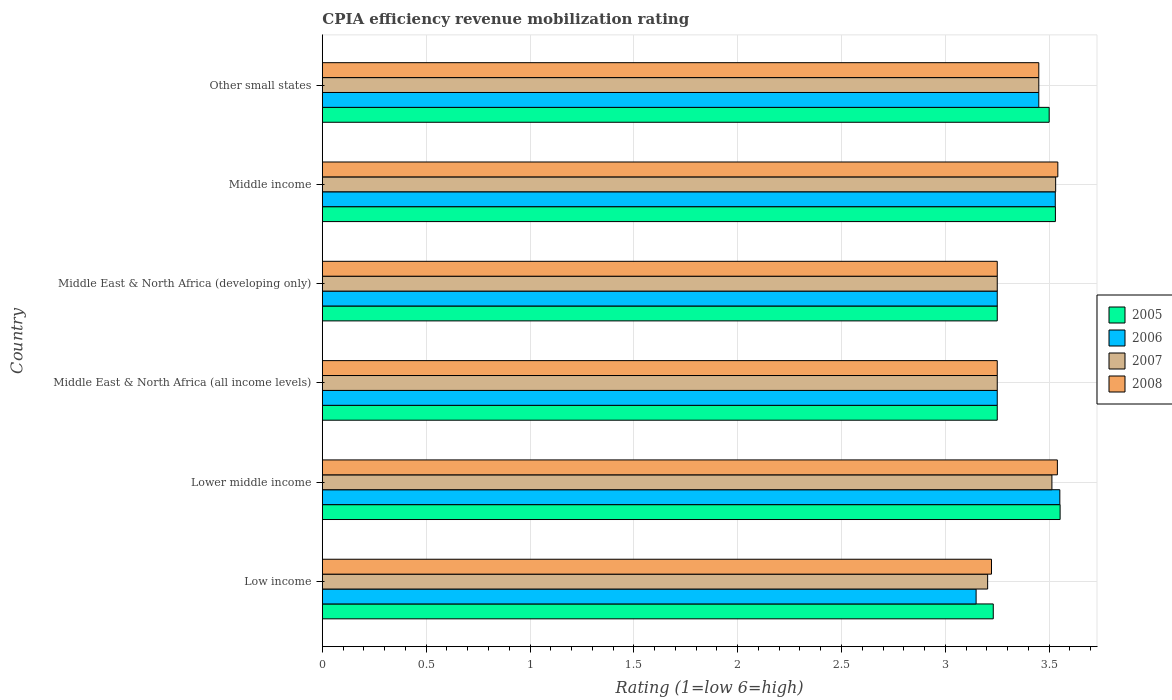How many different coloured bars are there?
Keep it short and to the point. 4. Are the number of bars per tick equal to the number of legend labels?
Your response must be concise. Yes. Are the number of bars on each tick of the Y-axis equal?
Offer a terse response. Yes. How many bars are there on the 2nd tick from the top?
Make the answer very short. 4. How many bars are there on the 1st tick from the bottom?
Ensure brevity in your answer.  4. In how many cases, is the number of bars for a given country not equal to the number of legend labels?
Provide a succinct answer. 0. Across all countries, what is the maximum CPIA rating in 2005?
Provide a short and direct response. 3.55. Across all countries, what is the minimum CPIA rating in 2007?
Provide a succinct answer. 3.2. In which country was the CPIA rating in 2007 minimum?
Provide a succinct answer. Low income. What is the total CPIA rating in 2005 in the graph?
Your response must be concise. 20.31. What is the difference between the CPIA rating in 2007 in Low income and that in Middle income?
Offer a very short reply. -0.33. What is the difference between the CPIA rating in 2006 in Lower middle income and the CPIA rating in 2008 in Middle income?
Give a very brief answer. 0.01. What is the average CPIA rating in 2008 per country?
Your answer should be compact. 3.38. What is the difference between the CPIA rating in 2006 and CPIA rating in 2007 in Middle East & North Africa (all income levels)?
Offer a terse response. 0. What is the ratio of the CPIA rating in 2005 in Middle East & North Africa (all income levels) to that in Middle East & North Africa (developing only)?
Provide a short and direct response. 1. What is the difference between the highest and the second highest CPIA rating in 2008?
Keep it short and to the point. 0. What is the difference between the highest and the lowest CPIA rating in 2008?
Offer a very short reply. 0.32. Is the sum of the CPIA rating in 2008 in Middle East & North Africa (all income levels) and Middle East & North Africa (developing only) greater than the maximum CPIA rating in 2006 across all countries?
Make the answer very short. Yes. Is it the case that in every country, the sum of the CPIA rating in 2005 and CPIA rating in 2007 is greater than the sum of CPIA rating in 2006 and CPIA rating in 2008?
Your answer should be very brief. No. What does the 4th bar from the top in Middle East & North Africa (developing only) represents?
Offer a very short reply. 2005. What does the 1st bar from the bottom in Middle income represents?
Ensure brevity in your answer.  2005. How many bars are there?
Give a very brief answer. 24. How many countries are there in the graph?
Your answer should be very brief. 6. Are the values on the major ticks of X-axis written in scientific E-notation?
Give a very brief answer. No. Where does the legend appear in the graph?
Your answer should be compact. Center right. How many legend labels are there?
Offer a terse response. 4. How are the legend labels stacked?
Your answer should be very brief. Vertical. What is the title of the graph?
Ensure brevity in your answer.  CPIA efficiency revenue mobilization rating. Does "1986" appear as one of the legend labels in the graph?
Offer a terse response. No. What is the label or title of the X-axis?
Keep it short and to the point. Rating (1=low 6=high). What is the label or title of the Y-axis?
Your response must be concise. Country. What is the Rating (1=low 6=high) of 2005 in Low income?
Your answer should be very brief. 3.23. What is the Rating (1=low 6=high) of 2006 in Low income?
Provide a succinct answer. 3.15. What is the Rating (1=low 6=high) of 2007 in Low income?
Your response must be concise. 3.2. What is the Rating (1=low 6=high) in 2008 in Low income?
Provide a short and direct response. 3.22. What is the Rating (1=low 6=high) in 2005 in Lower middle income?
Your answer should be very brief. 3.55. What is the Rating (1=low 6=high) in 2006 in Lower middle income?
Provide a succinct answer. 3.55. What is the Rating (1=low 6=high) of 2007 in Lower middle income?
Offer a very short reply. 3.51. What is the Rating (1=low 6=high) of 2008 in Lower middle income?
Provide a succinct answer. 3.54. What is the Rating (1=low 6=high) in 2006 in Middle East & North Africa (all income levels)?
Keep it short and to the point. 3.25. What is the Rating (1=low 6=high) of 2007 in Middle East & North Africa (all income levels)?
Offer a terse response. 3.25. What is the Rating (1=low 6=high) of 2008 in Middle East & North Africa (all income levels)?
Offer a terse response. 3.25. What is the Rating (1=low 6=high) of 2006 in Middle East & North Africa (developing only)?
Provide a succinct answer. 3.25. What is the Rating (1=low 6=high) in 2007 in Middle East & North Africa (developing only)?
Provide a succinct answer. 3.25. What is the Rating (1=low 6=high) of 2008 in Middle East & North Africa (developing only)?
Provide a succinct answer. 3.25. What is the Rating (1=low 6=high) of 2005 in Middle income?
Your answer should be compact. 3.53. What is the Rating (1=low 6=high) in 2006 in Middle income?
Offer a very short reply. 3.53. What is the Rating (1=low 6=high) in 2007 in Middle income?
Offer a very short reply. 3.53. What is the Rating (1=low 6=high) of 2008 in Middle income?
Your answer should be very brief. 3.54. What is the Rating (1=low 6=high) in 2006 in Other small states?
Offer a terse response. 3.45. What is the Rating (1=low 6=high) of 2007 in Other small states?
Your answer should be very brief. 3.45. What is the Rating (1=low 6=high) of 2008 in Other small states?
Offer a very short reply. 3.45. Across all countries, what is the maximum Rating (1=low 6=high) in 2005?
Give a very brief answer. 3.55. Across all countries, what is the maximum Rating (1=low 6=high) of 2006?
Your answer should be compact. 3.55. Across all countries, what is the maximum Rating (1=low 6=high) in 2007?
Give a very brief answer. 3.53. Across all countries, what is the maximum Rating (1=low 6=high) of 2008?
Your answer should be very brief. 3.54. Across all countries, what is the minimum Rating (1=low 6=high) in 2005?
Offer a very short reply. 3.23. Across all countries, what is the minimum Rating (1=low 6=high) in 2006?
Your answer should be very brief. 3.15. Across all countries, what is the minimum Rating (1=low 6=high) in 2007?
Offer a terse response. 3.2. Across all countries, what is the minimum Rating (1=low 6=high) in 2008?
Your answer should be compact. 3.22. What is the total Rating (1=low 6=high) of 2005 in the graph?
Your answer should be very brief. 20.31. What is the total Rating (1=low 6=high) in 2006 in the graph?
Your response must be concise. 20.18. What is the total Rating (1=low 6=high) of 2007 in the graph?
Your response must be concise. 20.2. What is the total Rating (1=low 6=high) in 2008 in the graph?
Ensure brevity in your answer.  20.25. What is the difference between the Rating (1=low 6=high) in 2005 in Low income and that in Lower middle income?
Provide a short and direct response. -0.32. What is the difference between the Rating (1=low 6=high) in 2006 in Low income and that in Lower middle income?
Provide a short and direct response. -0.4. What is the difference between the Rating (1=low 6=high) of 2007 in Low income and that in Lower middle income?
Provide a short and direct response. -0.31. What is the difference between the Rating (1=low 6=high) of 2008 in Low income and that in Lower middle income?
Give a very brief answer. -0.32. What is the difference between the Rating (1=low 6=high) of 2005 in Low income and that in Middle East & North Africa (all income levels)?
Ensure brevity in your answer.  -0.02. What is the difference between the Rating (1=low 6=high) of 2006 in Low income and that in Middle East & North Africa (all income levels)?
Keep it short and to the point. -0.1. What is the difference between the Rating (1=low 6=high) in 2007 in Low income and that in Middle East & North Africa (all income levels)?
Ensure brevity in your answer.  -0.05. What is the difference between the Rating (1=low 6=high) in 2008 in Low income and that in Middle East & North Africa (all income levels)?
Provide a succinct answer. -0.03. What is the difference between the Rating (1=low 6=high) in 2005 in Low income and that in Middle East & North Africa (developing only)?
Ensure brevity in your answer.  -0.02. What is the difference between the Rating (1=low 6=high) of 2006 in Low income and that in Middle East & North Africa (developing only)?
Keep it short and to the point. -0.1. What is the difference between the Rating (1=low 6=high) of 2007 in Low income and that in Middle East & North Africa (developing only)?
Your answer should be compact. -0.05. What is the difference between the Rating (1=low 6=high) in 2008 in Low income and that in Middle East & North Africa (developing only)?
Provide a succinct answer. -0.03. What is the difference between the Rating (1=low 6=high) in 2005 in Low income and that in Middle income?
Ensure brevity in your answer.  -0.3. What is the difference between the Rating (1=low 6=high) of 2006 in Low income and that in Middle income?
Your response must be concise. -0.38. What is the difference between the Rating (1=low 6=high) of 2007 in Low income and that in Middle income?
Keep it short and to the point. -0.33. What is the difference between the Rating (1=low 6=high) of 2008 in Low income and that in Middle income?
Your answer should be compact. -0.32. What is the difference between the Rating (1=low 6=high) of 2005 in Low income and that in Other small states?
Your response must be concise. -0.27. What is the difference between the Rating (1=low 6=high) in 2006 in Low income and that in Other small states?
Your response must be concise. -0.3. What is the difference between the Rating (1=low 6=high) of 2007 in Low income and that in Other small states?
Give a very brief answer. -0.25. What is the difference between the Rating (1=low 6=high) of 2008 in Low income and that in Other small states?
Your answer should be very brief. -0.23. What is the difference between the Rating (1=low 6=high) in 2005 in Lower middle income and that in Middle East & North Africa (all income levels)?
Offer a terse response. 0.3. What is the difference between the Rating (1=low 6=high) in 2006 in Lower middle income and that in Middle East & North Africa (all income levels)?
Your answer should be compact. 0.3. What is the difference between the Rating (1=low 6=high) in 2007 in Lower middle income and that in Middle East & North Africa (all income levels)?
Make the answer very short. 0.26. What is the difference between the Rating (1=low 6=high) of 2008 in Lower middle income and that in Middle East & North Africa (all income levels)?
Your response must be concise. 0.29. What is the difference between the Rating (1=low 6=high) of 2005 in Lower middle income and that in Middle East & North Africa (developing only)?
Offer a terse response. 0.3. What is the difference between the Rating (1=low 6=high) of 2006 in Lower middle income and that in Middle East & North Africa (developing only)?
Keep it short and to the point. 0.3. What is the difference between the Rating (1=low 6=high) of 2007 in Lower middle income and that in Middle East & North Africa (developing only)?
Offer a very short reply. 0.26. What is the difference between the Rating (1=low 6=high) in 2008 in Lower middle income and that in Middle East & North Africa (developing only)?
Keep it short and to the point. 0.29. What is the difference between the Rating (1=low 6=high) in 2005 in Lower middle income and that in Middle income?
Offer a terse response. 0.02. What is the difference between the Rating (1=low 6=high) of 2006 in Lower middle income and that in Middle income?
Your answer should be compact. 0.02. What is the difference between the Rating (1=low 6=high) in 2007 in Lower middle income and that in Middle income?
Make the answer very short. -0.02. What is the difference between the Rating (1=low 6=high) of 2008 in Lower middle income and that in Middle income?
Ensure brevity in your answer.  -0. What is the difference between the Rating (1=low 6=high) in 2005 in Lower middle income and that in Other small states?
Your answer should be very brief. 0.05. What is the difference between the Rating (1=low 6=high) of 2006 in Lower middle income and that in Other small states?
Provide a succinct answer. 0.1. What is the difference between the Rating (1=low 6=high) of 2007 in Lower middle income and that in Other small states?
Keep it short and to the point. 0.06. What is the difference between the Rating (1=low 6=high) of 2008 in Lower middle income and that in Other small states?
Provide a succinct answer. 0.09. What is the difference between the Rating (1=low 6=high) in 2007 in Middle East & North Africa (all income levels) and that in Middle East & North Africa (developing only)?
Provide a short and direct response. 0. What is the difference between the Rating (1=low 6=high) in 2005 in Middle East & North Africa (all income levels) and that in Middle income?
Make the answer very short. -0.28. What is the difference between the Rating (1=low 6=high) of 2006 in Middle East & North Africa (all income levels) and that in Middle income?
Your answer should be very brief. -0.28. What is the difference between the Rating (1=low 6=high) in 2007 in Middle East & North Africa (all income levels) and that in Middle income?
Your response must be concise. -0.28. What is the difference between the Rating (1=low 6=high) in 2008 in Middle East & North Africa (all income levels) and that in Middle income?
Provide a succinct answer. -0.29. What is the difference between the Rating (1=low 6=high) of 2008 in Middle East & North Africa (all income levels) and that in Other small states?
Your answer should be very brief. -0.2. What is the difference between the Rating (1=low 6=high) in 2005 in Middle East & North Africa (developing only) and that in Middle income?
Your answer should be very brief. -0.28. What is the difference between the Rating (1=low 6=high) of 2006 in Middle East & North Africa (developing only) and that in Middle income?
Offer a terse response. -0.28. What is the difference between the Rating (1=low 6=high) of 2007 in Middle East & North Africa (developing only) and that in Middle income?
Ensure brevity in your answer.  -0.28. What is the difference between the Rating (1=low 6=high) of 2008 in Middle East & North Africa (developing only) and that in Middle income?
Your answer should be very brief. -0.29. What is the difference between the Rating (1=low 6=high) in 2006 in Middle East & North Africa (developing only) and that in Other small states?
Your response must be concise. -0.2. What is the difference between the Rating (1=low 6=high) in 2006 in Middle income and that in Other small states?
Your answer should be compact. 0.08. What is the difference between the Rating (1=low 6=high) of 2007 in Middle income and that in Other small states?
Keep it short and to the point. 0.08. What is the difference between the Rating (1=low 6=high) of 2008 in Middle income and that in Other small states?
Your response must be concise. 0.09. What is the difference between the Rating (1=low 6=high) in 2005 in Low income and the Rating (1=low 6=high) in 2006 in Lower middle income?
Provide a succinct answer. -0.32. What is the difference between the Rating (1=low 6=high) in 2005 in Low income and the Rating (1=low 6=high) in 2007 in Lower middle income?
Your answer should be compact. -0.28. What is the difference between the Rating (1=low 6=high) of 2005 in Low income and the Rating (1=low 6=high) of 2008 in Lower middle income?
Provide a short and direct response. -0.31. What is the difference between the Rating (1=low 6=high) in 2006 in Low income and the Rating (1=low 6=high) in 2007 in Lower middle income?
Offer a very short reply. -0.36. What is the difference between the Rating (1=low 6=high) in 2006 in Low income and the Rating (1=low 6=high) in 2008 in Lower middle income?
Your answer should be compact. -0.39. What is the difference between the Rating (1=low 6=high) in 2007 in Low income and the Rating (1=low 6=high) in 2008 in Lower middle income?
Provide a succinct answer. -0.34. What is the difference between the Rating (1=low 6=high) of 2005 in Low income and the Rating (1=low 6=high) of 2006 in Middle East & North Africa (all income levels)?
Your answer should be compact. -0.02. What is the difference between the Rating (1=low 6=high) in 2005 in Low income and the Rating (1=low 6=high) in 2007 in Middle East & North Africa (all income levels)?
Your answer should be very brief. -0.02. What is the difference between the Rating (1=low 6=high) of 2005 in Low income and the Rating (1=low 6=high) of 2008 in Middle East & North Africa (all income levels)?
Offer a terse response. -0.02. What is the difference between the Rating (1=low 6=high) of 2006 in Low income and the Rating (1=low 6=high) of 2007 in Middle East & North Africa (all income levels)?
Provide a succinct answer. -0.1. What is the difference between the Rating (1=low 6=high) of 2006 in Low income and the Rating (1=low 6=high) of 2008 in Middle East & North Africa (all income levels)?
Ensure brevity in your answer.  -0.1. What is the difference between the Rating (1=low 6=high) of 2007 in Low income and the Rating (1=low 6=high) of 2008 in Middle East & North Africa (all income levels)?
Provide a succinct answer. -0.05. What is the difference between the Rating (1=low 6=high) in 2005 in Low income and the Rating (1=low 6=high) in 2006 in Middle East & North Africa (developing only)?
Offer a very short reply. -0.02. What is the difference between the Rating (1=low 6=high) in 2005 in Low income and the Rating (1=low 6=high) in 2007 in Middle East & North Africa (developing only)?
Provide a succinct answer. -0.02. What is the difference between the Rating (1=low 6=high) in 2005 in Low income and the Rating (1=low 6=high) in 2008 in Middle East & North Africa (developing only)?
Offer a terse response. -0.02. What is the difference between the Rating (1=low 6=high) of 2006 in Low income and the Rating (1=low 6=high) of 2007 in Middle East & North Africa (developing only)?
Your answer should be very brief. -0.1. What is the difference between the Rating (1=low 6=high) of 2006 in Low income and the Rating (1=low 6=high) of 2008 in Middle East & North Africa (developing only)?
Provide a short and direct response. -0.1. What is the difference between the Rating (1=low 6=high) in 2007 in Low income and the Rating (1=low 6=high) in 2008 in Middle East & North Africa (developing only)?
Your answer should be compact. -0.05. What is the difference between the Rating (1=low 6=high) of 2005 in Low income and the Rating (1=low 6=high) of 2006 in Middle income?
Provide a succinct answer. -0.3. What is the difference between the Rating (1=low 6=high) in 2005 in Low income and the Rating (1=low 6=high) in 2007 in Middle income?
Provide a succinct answer. -0.3. What is the difference between the Rating (1=low 6=high) of 2005 in Low income and the Rating (1=low 6=high) of 2008 in Middle income?
Make the answer very short. -0.31. What is the difference between the Rating (1=low 6=high) of 2006 in Low income and the Rating (1=low 6=high) of 2007 in Middle income?
Your response must be concise. -0.38. What is the difference between the Rating (1=low 6=high) of 2006 in Low income and the Rating (1=low 6=high) of 2008 in Middle income?
Offer a very short reply. -0.39. What is the difference between the Rating (1=low 6=high) of 2007 in Low income and the Rating (1=low 6=high) of 2008 in Middle income?
Give a very brief answer. -0.34. What is the difference between the Rating (1=low 6=high) of 2005 in Low income and the Rating (1=low 6=high) of 2006 in Other small states?
Make the answer very short. -0.22. What is the difference between the Rating (1=low 6=high) of 2005 in Low income and the Rating (1=low 6=high) of 2007 in Other small states?
Give a very brief answer. -0.22. What is the difference between the Rating (1=low 6=high) in 2005 in Low income and the Rating (1=low 6=high) in 2008 in Other small states?
Make the answer very short. -0.22. What is the difference between the Rating (1=low 6=high) of 2006 in Low income and the Rating (1=low 6=high) of 2007 in Other small states?
Ensure brevity in your answer.  -0.3. What is the difference between the Rating (1=low 6=high) in 2006 in Low income and the Rating (1=low 6=high) in 2008 in Other small states?
Offer a terse response. -0.3. What is the difference between the Rating (1=low 6=high) of 2007 in Low income and the Rating (1=low 6=high) of 2008 in Other small states?
Provide a short and direct response. -0.25. What is the difference between the Rating (1=low 6=high) in 2005 in Lower middle income and the Rating (1=low 6=high) in 2006 in Middle East & North Africa (all income levels)?
Your response must be concise. 0.3. What is the difference between the Rating (1=low 6=high) of 2005 in Lower middle income and the Rating (1=low 6=high) of 2007 in Middle East & North Africa (all income levels)?
Offer a very short reply. 0.3. What is the difference between the Rating (1=low 6=high) of 2005 in Lower middle income and the Rating (1=low 6=high) of 2008 in Middle East & North Africa (all income levels)?
Make the answer very short. 0.3. What is the difference between the Rating (1=low 6=high) of 2006 in Lower middle income and the Rating (1=low 6=high) of 2007 in Middle East & North Africa (all income levels)?
Make the answer very short. 0.3. What is the difference between the Rating (1=low 6=high) in 2006 in Lower middle income and the Rating (1=low 6=high) in 2008 in Middle East & North Africa (all income levels)?
Provide a short and direct response. 0.3. What is the difference between the Rating (1=low 6=high) of 2007 in Lower middle income and the Rating (1=low 6=high) of 2008 in Middle East & North Africa (all income levels)?
Provide a succinct answer. 0.26. What is the difference between the Rating (1=low 6=high) of 2005 in Lower middle income and the Rating (1=low 6=high) of 2006 in Middle East & North Africa (developing only)?
Offer a very short reply. 0.3. What is the difference between the Rating (1=low 6=high) in 2005 in Lower middle income and the Rating (1=low 6=high) in 2007 in Middle East & North Africa (developing only)?
Offer a very short reply. 0.3. What is the difference between the Rating (1=low 6=high) in 2005 in Lower middle income and the Rating (1=low 6=high) in 2008 in Middle East & North Africa (developing only)?
Your answer should be compact. 0.3. What is the difference between the Rating (1=low 6=high) in 2006 in Lower middle income and the Rating (1=low 6=high) in 2007 in Middle East & North Africa (developing only)?
Offer a very short reply. 0.3. What is the difference between the Rating (1=low 6=high) of 2006 in Lower middle income and the Rating (1=low 6=high) of 2008 in Middle East & North Africa (developing only)?
Your response must be concise. 0.3. What is the difference between the Rating (1=low 6=high) in 2007 in Lower middle income and the Rating (1=low 6=high) in 2008 in Middle East & North Africa (developing only)?
Your answer should be very brief. 0.26. What is the difference between the Rating (1=low 6=high) in 2005 in Lower middle income and the Rating (1=low 6=high) in 2006 in Middle income?
Offer a very short reply. 0.02. What is the difference between the Rating (1=low 6=high) of 2005 in Lower middle income and the Rating (1=low 6=high) of 2007 in Middle income?
Offer a terse response. 0.02. What is the difference between the Rating (1=low 6=high) in 2005 in Lower middle income and the Rating (1=low 6=high) in 2008 in Middle income?
Provide a short and direct response. 0.01. What is the difference between the Rating (1=low 6=high) of 2006 in Lower middle income and the Rating (1=low 6=high) of 2007 in Middle income?
Make the answer very short. 0.02. What is the difference between the Rating (1=low 6=high) in 2006 in Lower middle income and the Rating (1=low 6=high) in 2008 in Middle income?
Provide a succinct answer. 0.01. What is the difference between the Rating (1=low 6=high) of 2007 in Lower middle income and the Rating (1=low 6=high) of 2008 in Middle income?
Make the answer very short. -0.03. What is the difference between the Rating (1=low 6=high) of 2005 in Lower middle income and the Rating (1=low 6=high) of 2006 in Other small states?
Make the answer very short. 0.1. What is the difference between the Rating (1=low 6=high) of 2005 in Lower middle income and the Rating (1=low 6=high) of 2007 in Other small states?
Provide a succinct answer. 0.1. What is the difference between the Rating (1=low 6=high) of 2005 in Lower middle income and the Rating (1=low 6=high) of 2008 in Other small states?
Keep it short and to the point. 0.1. What is the difference between the Rating (1=low 6=high) in 2006 in Lower middle income and the Rating (1=low 6=high) in 2007 in Other small states?
Your answer should be compact. 0.1. What is the difference between the Rating (1=low 6=high) of 2006 in Lower middle income and the Rating (1=low 6=high) of 2008 in Other small states?
Ensure brevity in your answer.  0.1. What is the difference between the Rating (1=low 6=high) of 2007 in Lower middle income and the Rating (1=low 6=high) of 2008 in Other small states?
Provide a short and direct response. 0.06. What is the difference between the Rating (1=low 6=high) in 2005 in Middle East & North Africa (all income levels) and the Rating (1=low 6=high) in 2007 in Middle East & North Africa (developing only)?
Keep it short and to the point. 0. What is the difference between the Rating (1=low 6=high) of 2006 in Middle East & North Africa (all income levels) and the Rating (1=low 6=high) of 2008 in Middle East & North Africa (developing only)?
Offer a very short reply. 0. What is the difference between the Rating (1=low 6=high) in 2005 in Middle East & North Africa (all income levels) and the Rating (1=low 6=high) in 2006 in Middle income?
Give a very brief answer. -0.28. What is the difference between the Rating (1=low 6=high) in 2005 in Middle East & North Africa (all income levels) and the Rating (1=low 6=high) in 2007 in Middle income?
Offer a very short reply. -0.28. What is the difference between the Rating (1=low 6=high) in 2005 in Middle East & North Africa (all income levels) and the Rating (1=low 6=high) in 2008 in Middle income?
Provide a short and direct response. -0.29. What is the difference between the Rating (1=low 6=high) of 2006 in Middle East & North Africa (all income levels) and the Rating (1=low 6=high) of 2007 in Middle income?
Give a very brief answer. -0.28. What is the difference between the Rating (1=low 6=high) in 2006 in Middle East & North Africa (all income levels) and the Rating (1=low 6=high) in 2008 in Middle income?
Your response must be concise. -0.29. What is the difference between the Rating (1=low 6=high) in 2007 in Middle East & North Africa (all income levels) and the Rating (1=low 6=high) in 2008 in Middle income?
Give a very brief answer. -0.29. What is the difference between the Rating (1=low 6=high) in 2005 in Middle East & North Africa (all income levels) and the Rating (1=low 6=high) in 2007 in Other small states?
Offer a terse response. -0.2. What is the difference between the Rating (1=low 6=high) of 2007 in Middle East & North Africa (all income levels) and the Rating (1=low 6=high) of 2008 in Other small states?
Ensure brevity in your answer.  -0.2. What is the difference between the Rating (1=low 6=high) of 2005 in Middle East & North Africa (developing only) and the Rating (1=low 6=high) of 2006 in Middle income?
Offer a terse response. -0.28. What is the difference between the Rating (1=low 6=high) of 2005 in Middle East & North Africa (developing only) and the Rating (1=low 6=high) of 2007 in Middle income?
Give a very brief answer. -0.28. What is the difference between the Rating (1=low 6=high) of 2005 in Middle East & North Africa (developing only) and the Rating (1=low 6=high) of 2008 in Middle income?
Provide a succinct answer. -0.29. What is the difference between the Rating (1=low 6=high) of 2006 in Middle East & North Africa (developing only) and the Rating (1=low 6=high) of 2007 in Middle income?
Offer a terse response. -0.28. What is the difference between the Rating (1=low 6=high) in 2006 in Middle East & North Africa (developing only) and the Rating (1=low 6=high) in 2008 in Middle income?
Make the answer very short. -0.29. What is the difference between the Rating (1=low 6=high) in 2007 in Middle East & North Africa (developing only) and the Rating (1=low 6=high) in 2008 in Middle income?
Provide a succinct answer. -0.29. What is the difference between the Rating (1=low 6=high) in 2005 in Middle East & North Africa (developing only) and the Rating (1=low 6=high) in 2007 in Other small states?
Keep it short and to the point. -0.2. What is the difference between the Rating (1=low 6=high) in 2006 in Middle East & North Africa (developing only) and the Rating (1=low 6=high) in 2007 in Other small states?
Offer a very short reply. -0.2. What is the difference between the Rating (1=low 6=high) of 2005 in Middle income and the Rating (1=low 6=high) of 2008 in Other small states?
Provide a short and direct response. 0.08. What is the difference between the Rating (1=low 6=high) of 2006 in Middle income and the Rating (1=low 6=high) of 2007 in Other small states?
Your response must be concise. 0.08. What is the difference between the Rating (1=low 6=high) of 2006 in Middle income and the Rating (1=low 6=high) of 2008 in Other small states?
Give a very brief answer. 0.08. What is the difference between the Rating (1=low 6=high) of 2007 in Middle income and the Rating (1=low 6=high) of 2008 in Other small states?
Provide a short and direct response. 0.08. What is the average Rating (1=low 6=high) in 2005 per country?
Keep it short and to the point. 3.39. What is the average Rating (1=low 6=high) of 2006 per country?
Provide a short and direct response. 3.36. What is the average Rating (1=low 6=high) of 2007 per country?
Provide a succinct answer. 3.37. What is the average Rating (1=low 6=high) of 2008 per country?
Offer a very short reply. 3.38. What is the difference between the Rating (1=low 6=high) in 2005 and Rating (1=low 6=high) in 2006 in Low income?
Offer a very short reply. 0.08. What is the difference between the Rating (1=low 6=high) in 2005 and Rating (1=low 6=high) in 2007 in Low income?
Your answer should be compact. 0.03. What is the difference between the Rating (1=low 6=high) in 2005 and Rating (1=low 6=high) in 2008 in Low income?
Offer a terse response. 0.01. What is the difference between the Rating (1=low 6=high) of 2006 and Rating (1=low 6=high) of 2007 in Low income?
Provide a succinct answer. -0.06. What is the difference between the Rating (1=low 6=high) in 2006 and Rating (1=low 6=high) in 2008 in Low income?
Your response must be concise. -0.07. What is the difference between the Rating (1=low 6=high) of 2007 and Rating (1=low 6=high) of 2008 in Low income?
Give a very brief answer. -0.02. What is the difference between the Rating (1=low 6=high) of 2005 and Rating (1=low 6=high) of 2006 in Lower middle income?
Provide a short and direct response. 0. What is the difference between the Rating (1=low 6=high) of 2005 and Rating (1=low 6=high) of 2007 in Lower middle income?
Your answer should be compact. 0.04. What is the difference between the Rating (1=low 6=high) of 2005 and Rating (1=low 6=high) of 2008 in Lower middle income?
Provide a short and direct response. 0.01. What is the difference between the Rating (1=low 6=high) in 2006 and Rating (1=low 6=high) in 2007 in Lower middle income?
Provide a short and direct response. 0.04. What is the difference between the Rating (1=low 6=high) of 2006 and Rating (1=low 6=high) of 2008 in Lower middle income?
Provide a short and direct response. 0.01. What is the difference between the Rating (1=low 6=high) of 2007 and Rating (1=low 6=high) of 2008 in Lower middle income?
Provide a succinct answer. -0.03. What is the difference between the Rating (1=low 6=high) in 2005 and Rating (1=low 6=high) in 2006 in Middle East & North Africa (all income levels)?
Your answer should be compact. 0. What is the difference between the Rating (1=low 6=high) in 2005 and Rating (1=low 6=high) in 2007 in Middle East & North Africa (all income levels)?
Offer a terse response. 0. What is the difference between the Rating (1=low 6=high) of 2005 and Rating (1=low 6=high) of 2008 in Middle East & North Africa (all income levels)?
Provide a succinct answer. 0. What is the difference between the Rating (1=low 6=high) of 2006 and Rating (1=low 6=high) of 2007 in Middle East & North Africa (all income levels)?
Make the answer very short. 0. What is the difference between the Rating (1=low 6=high) of 2006 and Rating (1=low 6=high) of 2008 in Middle East & North Africa (all income levels)?
Ensure brevity in your answer.  0. What is the difference between the Rating (1=low 6=high) of 2007 and Rating (1=low 6=high) of 2008 in Middle East & North Africa (all income levels)?
Provide a succinct answer. 0. What is the difference between the Rating (1=low 6=high) of 2005 and Rating (1=low 6=high) of 2008 in Middle East & North Africa (developing only)?
Your answer should be very brief. 0. What is the difference between the Rating (1=low 6=high) of 2006 and Rating (1=low 6=high) of 2008 in Middle East & North Africa (developing only)?
Your answer should be very brief. 0. What is the difference between the Rating (1=low 6=high) in 2005 and Rating (1=low 6=high) in 2006 in Middle income?
Offer a very short reply. 0. What is the difference between the Rating (1=low 6=high) in 2005 and Rating (1=low 6=high) in 2007 in Middle income?
Offer a terse response. -0. What is the difference between the Rating (1=low 6=high) in 2005 and Rating (1=low 6=high) in 2008 in Middle income?
Your answer should be very brief. -0.01. What is the difference between the Rating (1=low 6=high) in 2006 and Rating (1=low 6=high) in 2007 in Middle income?
Your response must be concise. -0. What is the difference between the Rating (1=low 6=high) of 2006 and Rating (1=low 6=high) of 2008 in Middle income?
Provide a succinct answer. -0.01. What is the difference between the Rating (1=low 6=high) in 2007 and Rating (1=low 6=high) in 2008 in Middle income?
Your answer should be very brief. -0.01. What is the difference between the Rating (1=low 6=high) in 2005 and Rating (1=low 6=high) in 2008 in Other small states?
Provide a short and direct response. 0.05. What is the ratio of the Rating (1=low 6=high) of 2005 in Low income to that in Lower middle income?
Your answer should be very brief. 0.91. What is the ratio of the Rating (1=low 6=high) of 2006 in Low income to that in Lower middle income?
Provide a short and direct response. 0.89. What is the ratio of the Rating (1=low 6=high) of 2007 in Low income to that in Lower middle income?
Your answer should be compact. 0.91. What is the ratio of the Rating (1=low 6=high) in 2008 in Low income to that in Lower middle income?
Ensure brevity in your answer.  0.91. What is the ratio of the Rating (1=low 6=high) of 2005 in Low income to that in Middle East & North Africa (all income levels)?
Keep it short and to the point. 0.99. What is the ratio of the Rating (1=low 6=high) in 2006 in Low income to that in Middle East & North Africa (all income levels)?
Make the answer very short. 0.97. What is the ratio of the Rating (1=low 6=high) in 2007 in Low income to that in Middle East & North Africa (all income levels)?
Ensure brevity in your answer.  0.99. What is the ratio of the Rating (1=low 6=high) in 2008 in Low income to that in Middle East & North Africa (all income levels)?
Offer a very short reply. 0.99. What is the ratio of the Rating (1=low 6=high) of 2006 in Low income to that in Middle East & North Africa (developing only)?
Your answer should be very brief. 0.97. What is the ratio of the Rating (1=low 6=high) in 2007 in Low income to that in Middle East & North Africa (developing only)?
Your answer should be compact. 0.99. What is the ratio of the Rating (1=low 6=high) in 2008 in Low income to that in Middle East & North Africa (developing only)?
Your answer should be very brief. 0.99. What is the ratio of the Rating (1=low 6=high) of 2005 in Low income to that in Middle income?
Provide a succinct answer. 0.92. What is the ratio of the Rating (1=low 6=high) of 2006 in Low income to that in Middle income?
Give a very brief answer. 0.89. What is the ratio of the Rating (1=low 6=high) in 2007 in Low income to that in Middle income?
Keep it short and to the point. 0.91. What is the ratio of the Rating (1=low 6=high) in 2008 in Low income to that in Middle income?
Give a very brief answer. 0.91. What is the ratio of the Rating (1=low 6=high) of 2006 in Low income to that in Other small states?
Your answer should be compact. 0.91. What is the ratio of the Rating (1=low 6=high) in 2008 in Low income to that in Other small states?
Provide a succinct answer. 0.93. What is the ratio of the Rating (1=low 6=high) in 2005 in Lower middle income to that in Middle East & North Africa (all income levels)?
Provide a short and direct response. 1.09. What is the ratio of the Rating (1=low 6=high) of 2006 in Lower middle income to that in Middle East & North Africa (all income levels)?
Your answer should be very brief. 1.09. What is the ratio of the Rating (1=low 6=high) in 2007 in Lower middle income to that in Middle East & North Africa (all income levels)?
Make the answer very short. 1.08. What is the ratio of the Rating (1=low 6=high) in 2008 in Lower middle income to that in Middle East & North Africa (all income levels)?
Offer a terse response. 1.09. What is the ratio of the Rating (1=low 6=high) in 2005 in Lower middle income to that in Middle East & North Africa (developing only)?
Give a very brief answer. 1.09. What is the ratio of the Rating (1=low 6=high) of 2006 in Lower middle income to that in Middle East & North Africa (developing only)?
Your answer should be compact. 1.09. What is the ratio of the Rating (1=low 6=high) in 2007 in Lower middle income to that in Middle East & North Africa (developing only)?
Ensure brevity in your answer.  1.08. What is the ratio of the Rating (1=low 6=high) of 2008 in Lower middle income to that in Middle East & North Africa (developing only)?
Ensure brevity in your answer.  1.09. What is the ratio of the Rating (1=low 6=high) of 2005 in Lower middle income to that in Middle income?
Your answer should be very brief. 1.01. What is the ratio of the Rating (1=low 6=high) of 2006 in Lower middle income to that in Middle income?
Make the answer very short. 1.01. What is the ratio of the Rating (1=low 6=high) of 2006 in Lower middle income to that in Other small states?
Offer a very short reply. 1.03. What is the ratio of the Rating (1=low 6=high) in 2007 in Lower middle income to that in Other small states?
Offer a terse response. 1.02. What is the ratio of the Rating (1=low 6=high) of 2008 in Lower middle income to that in Other small states?
Offer a terse response. 1.03. What is the ratio of the Rating (1=low 6=high) in 2005 in Middle East & North Africa (all income levels) to that in Middle East & North Africa (developing only)?
Offer a very short reply. 1. What is the ratio of the Rating (1=low 6=high) in 2007 in Middle East & North Africa (all income levels) to that in Middle East & North Africa (developing only)?
Provide a short and direct response. 1. What is the ratio of the Rating (1=low 6=high) of 2008 in Middle East & North Africa (all income levels) to that in Middle East & North Africa (developing only)?
Offer a very short reply. 1. What is the ratio of the Rating (1=low 6=high) of 2005 in Middle East & North Africa (all income levels) to that in Middle income?
Provide a succinct answer. 0.92. What is the ratio of the Rating (1=low 6=high) in 2006 in Middle East & North Africa (all income levels) to that in Middle income?
Offer a terse response. 0.92. What is the ratio of the Rating (1=low 6=high) of 2007 in Middle East & North Africa (all income levels) to that in Middle income?
Provide a short and direct response. 0.92. What is the ratio of the Rating (1=low 6=high) of 2008 in Middle East & North Africa (all income levels) to that in Middle income?
Provide a succinct answer. 0.92. What is the ratio of the Rating (1=low 6=high) in 2005 in Middle East & North Africa (all income levels) to that in Other small states?
Your answer should be compact. 0.93. What is the ratio of the Rating (1=low 6=high) in 2006 in Middle East & North Africa (all income levels) to that in Other small states?
Ensure brevity in your answer.  0.94. What is the ratio of the Rating (1=low 6=high) in 2007 in Middle East & North Africa (all income levels) to that in Other small states?
Your answer should be compact. 0.94. What is the ratio of the Rating (1=low 6=high) in 2008 in Middle East & North Africa (all income levels) to that in Other small states?
Offer a terse response. 0.94. What is the ratio of the Rating (1=low 6=high) of 2005 in Middle East & North Africa (developing only) to that in Middle income?
Provide a short and direct response. 0.92. What is the ratio of the Rating (1=low 6=high) of 2006 in Middle East & North Africa (developing only) to that in Middle income?
Give a very brief answer. 0.92. What is the ratio of the Rating (1=low 6=high) in 2007 in Middle East & North Africa (developing only) to that in Middle income?
Your answer should be very brief. 0.92. What is the ratio of the Rating (1=low 6=high) of 2008 in Middle East & North Africa (developing only) to that in Middle income?
Keep it short and to the point. 0.92. What is the ratio of the Rating (1=low 6=high) in 2006 in Middle East & North Africa (developing only) to that in Other small states?
Make the answer very short. 0.94. What is the ratio of the Rating (1=low 6=high) in 2007 in Middle East & North Africa (developing only) to that in Other small states?
Provide a succinct answer. 0.94. What is the ratio of the Rating (1=low 6=high) of 2008 in Middle East & North Africa (developing only) to that in Other small states?
Keep it short and to the point. 0.94. What is the ratio of the Rating (1=low 6=high) in 2005 in Middle income to that in Other small states?
Your answer should be compact. 1.01. What is the ratio of the Rating (1=low 6=high) of 2006 in Middle income to that in Other small states?
Make the answer very short. 1.02. What is the ratio of the Rating (1=low 6=high) in 2007 in Middle income to that in Other small states?
Your response must be concise. 1.02. What is the ratio of the Rating (1=low 6=high) in 2008 in Middle income to that in Other small states?
Offer a very short reply. 1.03. What is the difference between the highest and the second highest Rating (1=low 6=high) in 2005?
Your answer should be compact. 0.02. What is the difference between the highest and the second highest Rating (1=low 6=high) in 2006?
Your response must be concise. 0.02. What is the difference between the highest and the second highest Rating (1=low 6=high) in 2007?
Your response must be concise. 0.02. What is the difference between the highest and the second highest Rating (1=low 6=high) in 2008?
Your response must be concise. 0. What is the difference between the highest and the lowest Rating (1=low 6=high) of 2005?
Keep it short and to the point. 0.32. What is the difference between the highest and the lowest Rating (1=low 6=high) in 2006?
Your answer should be very brief. 0.4. What is the difference between the highest and the lowest Rating (1=low 6=high) in 2007?
Provide a short and direct response. 0.33. What is the difference between the highest and the lowest Rating (1=low 6=high) in 2008?
Your answer should be very brief. 0.32. 